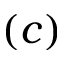Convert formula to latex. <formula><loc_0><loc_0><loc_500><loc_500>( c )</formula> 